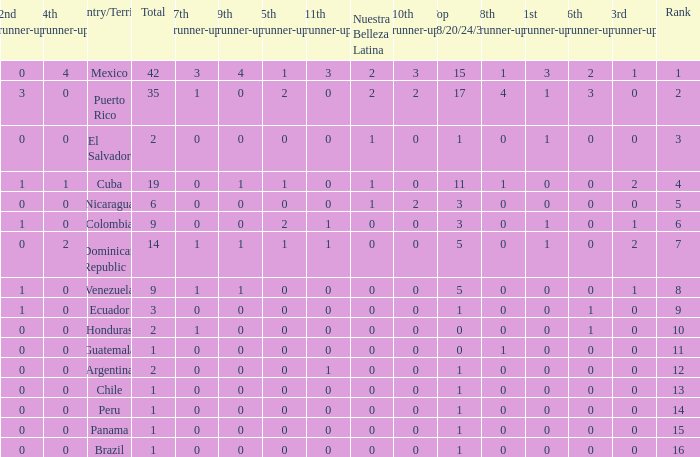What is the 7th runner-up of the country with a 10th runner-up greater than 0, a 9th runner-up greater than 0, and an 8th runner-up greater than 1? None. 